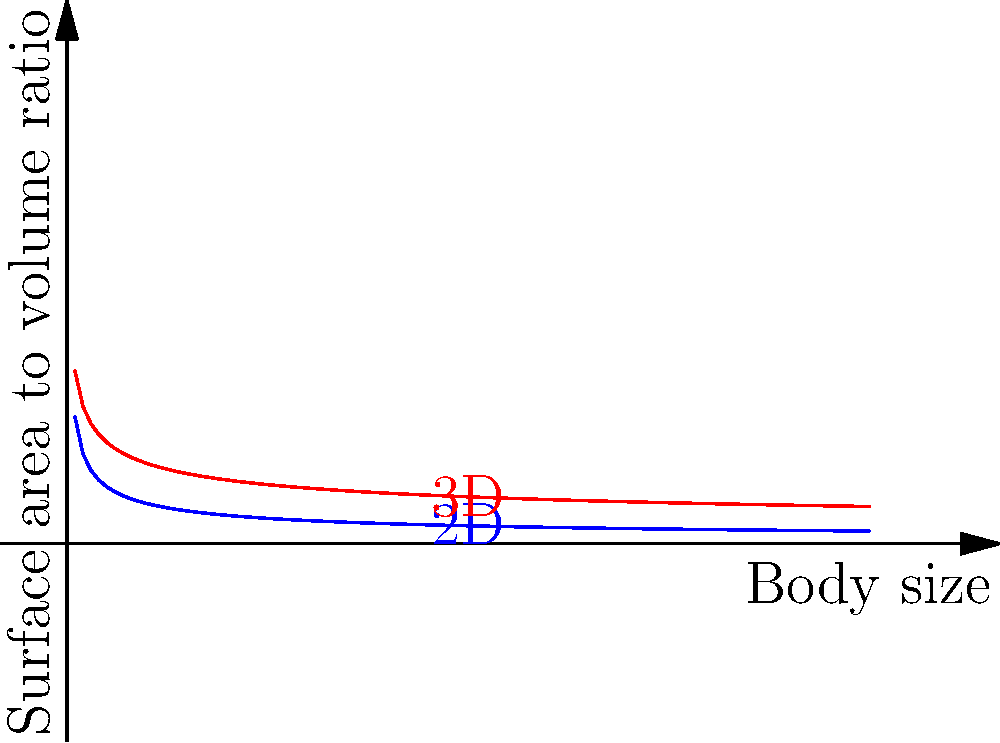Consider an insect species adapting to high-altitude environments. The surface area-to-volume ratio is crucial for gas exchange and temperature regulation. Given that the surface area-to-volume ratio for a 2D shape (like a flat insect) is proportional to $L^{-1/2}$ and for a 3D shape is proportional to $L^{-1/3}$, where $L$ is a characteristic length, use the calculus of variations to determine the optimal body shape (2D or 3D) for maximizing gas exchange efficiency as body size increases. What is the mathematical reason for this optimal shape? To solve this problem, we'll follow these steps:

1) First, let's define our functions:
   For 2D: $f(L) = kL^{-1/2}$
   For 3D: $g(L) = cL^{-1/3}$
   Where $k$ and $c$ are constants.

2) To compare these functions, we need to look at their derivatives with respect to $L$:
   $f'(L) = -\frac{1}{2}kL^{-3/2}$
   $g'(L) = -\frac{1}{3}cL^{-4/3}$

3) The derivatives tell us how quickly the surface area-to-volume ratio changes as body size increases.

4) To compare the rate of change, we can look at the limit of the ratio of these derivatives as $L$ approaches infinity:

   $\lim_{L \to \infty} \frac{f'(L)}{g'(L)} = \lim_{L \to \infty} \frac{-\frac{1}{2}kL^{-3/2}}{-\frac{1}{3}cL^{-4/3}} = \lim_{L \to \infty} \frac{3k}{2c}L^{-1/6} = 0$

5) This limit approaching 0 means that as body size increases, the rate of decrease in the surface area-to-volume ratio for the 2D shape becomes much faster than for the 3D shape.

6) Therefore, for larger body sizes, the 3D shape maintains a higher surface area-to-volume ratio, making it more efficient for gas exchange and temperature regulation.

The mathematical reason for this is the slower rate of decrease in the surface area-to-volume ratio for 3D shapes as size increases, as evidenced by the limit of the ratio of derivatives approaching zero.
Answer: 3D shape; slower decrease rate of surface area-to-volume ratio as size increases. 